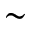Convert formula to latex. <formula><loc_0><loc_0><loc_500><loc_500>\sim</formula> 